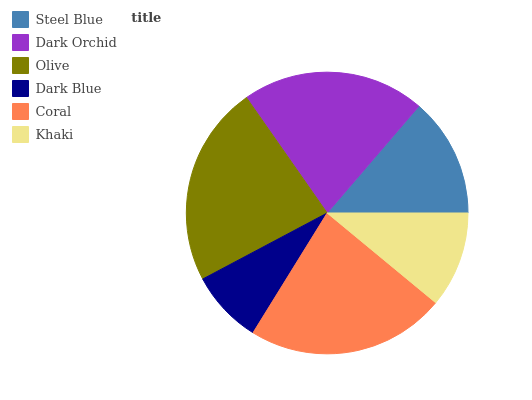Is Dark Blue the minimum?
Answer yes or no. Yes. Is Olive the maximum?
Answer yes or no. Yes. Is Dark Orchid the minimum?
Answer yes or no. No. Is Dark Orchid the maximum?
Answer yes or no. No. Is Dark Orchid greater than Steel Blue?
Answer yes or no. Yes. Is Steel Blue less than Dark Orchid?
Answer yes or no. Yes. Is Steel Blue greater than Dark Orchid?
Answer yes or no. No. Is Dark Orchid less than Steel Blue?
Answer yes or no. No. Is Dark Orchid the high median?
Answer yes or no. Yes. Is Steel Blue the low median?
Answer yes or no. Yes. Is Steel Blue the high median?
Answer yes or no. No. Is Dark Blue the low median?
Answer yes or no. No. 